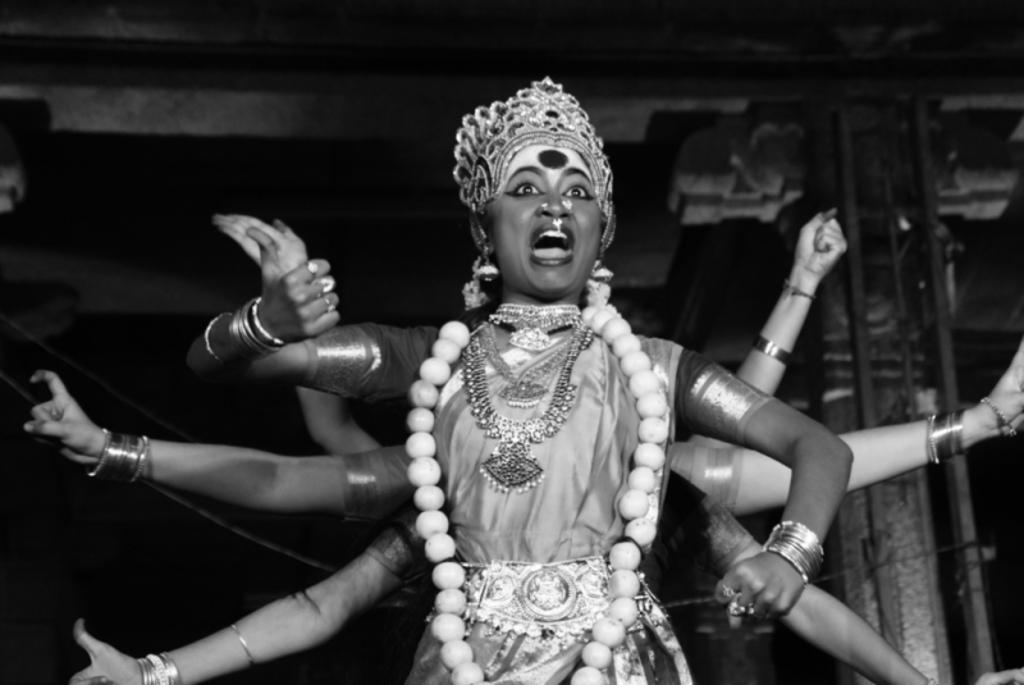Could you give a brief overview of what you see in this image? In this black and white picture there is a woman standing. She is wearing a crown and ornaments. There is a garland around her neck. Behind her there are many hands of the people. The background is dark. 